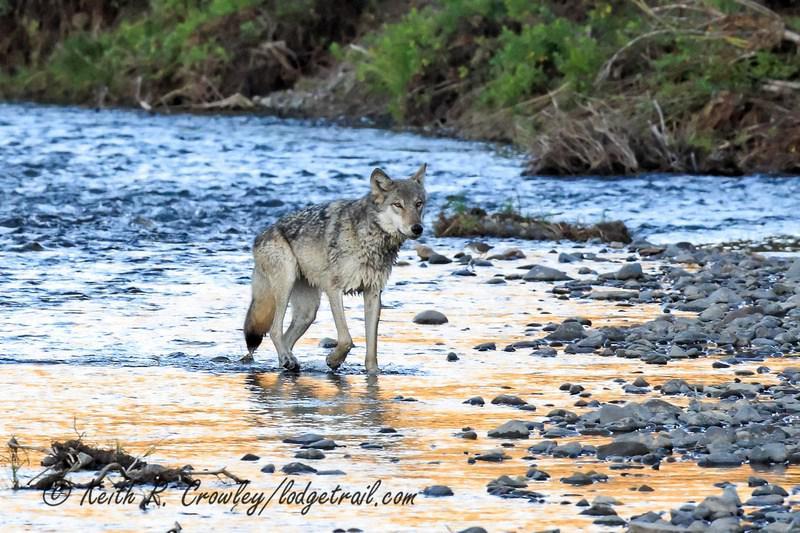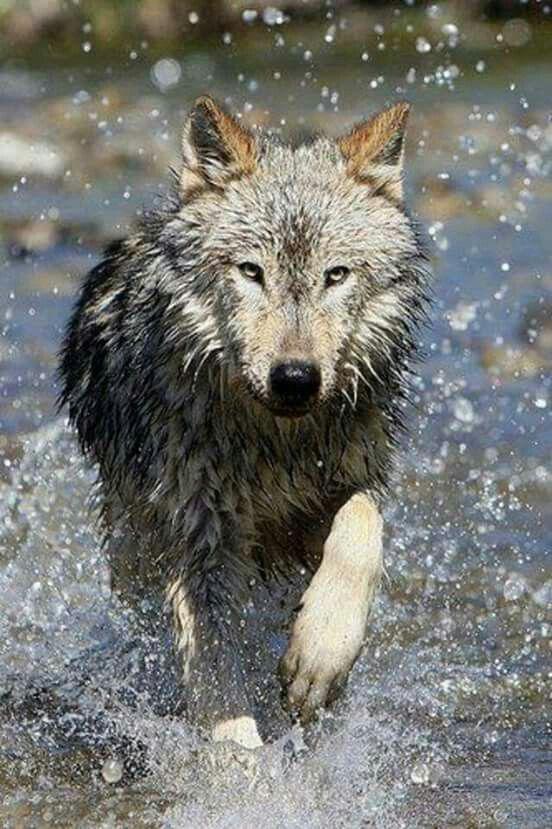The first image is the image on the left, the second image is the image on the right. Assess this claim about the two images: "One image features a wolf on snowy ground, and the other includes a body of water and at least one wolf.". Correct or not? Answer yes or no. No. The first image is the image on the left, the second image is the image on the right. Examine the images to the left and right. Is the description "A single wolf is in a watery area in the image on the right." accurate? Answer yes or no. Yes. 